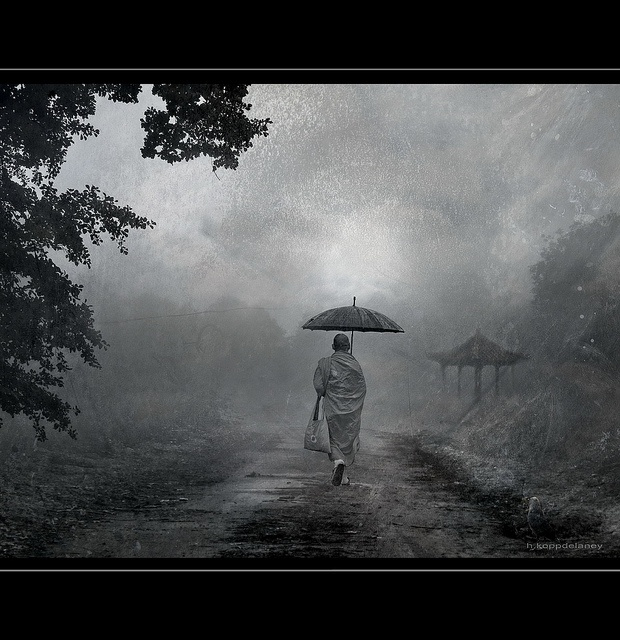Describe the objects in this image and their specific colors. I can see people in black, gray, and purple tones, umbrella in black, gray, and darkgray tones, and handbag in black and gray tones in this image. 